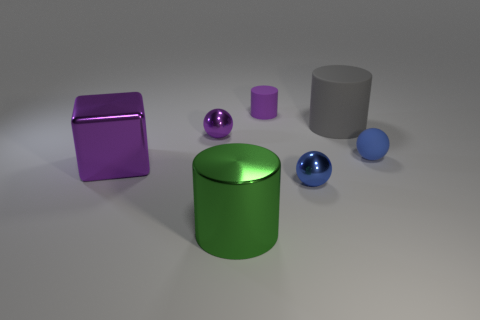How many objects are there in total, and can you categorize them by shape? There are six objects in total, consisting of two spheres, two cylinders, and two blocks. Specifically, there is one large blue sphere and one small blue sphere, one large green cylinder and one small purple cylinder, and two blocks, one of which is large and purple, and another which appears to be a medium-sized neutral colored block. 